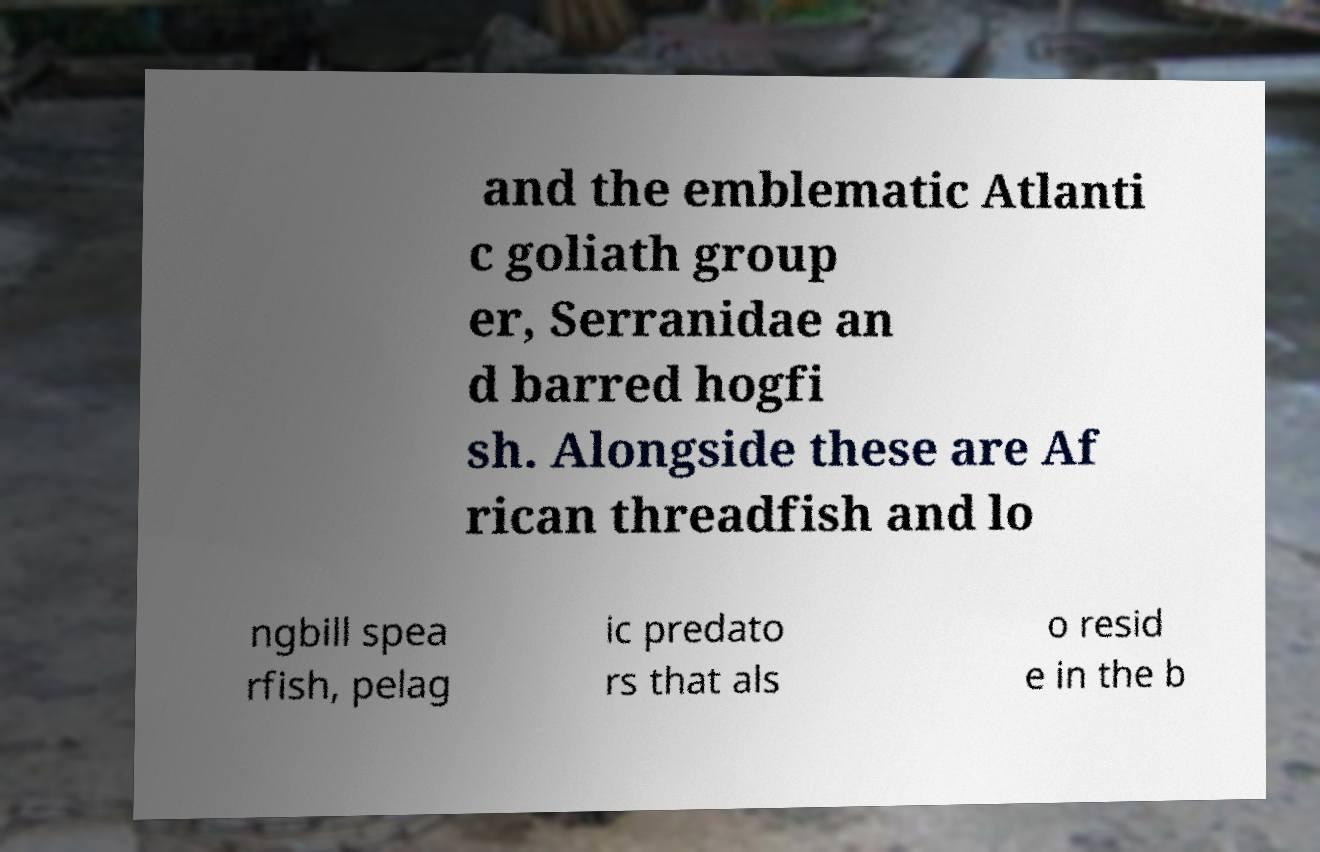Please identify and transcribe the text found in this image. and the emblematic Atlanti c goliath group er, Serranidae an d barred hogfi sh. Alongside these are Af rican threadfish and lo ngbill spea rfish, pelag ic predato rs that als o resid e in the b 